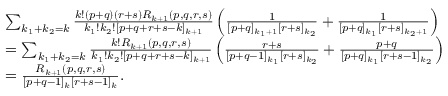Convert formula to latex. <formula><loc_0><loc_0><loc_500><loc_500>\begin{array} { r l } & { \sum _ { k _ { 1 } + k _ { 2 } = k } \frac { k ! ( p + q ) ( r + s ) R _ { k + 1 } ( p , q , r , s ) } { k _ { 1 } ! k _ { 2 } ! [ p + q + r + s - k ] _ { k + 1 } } \left ( \frac { 1 } { [ p + q ] _ { k _ { 1 } + 1 } [ r + s ] _ { k _ { 2 } } } + \frac { 1 } { [ p + q ] _ { k _ { 1 } } [ r + s ] _ { k _ { 2 } + 1 } } \right ) } \\ & { = \sum _ { k _ { 1 } + k _ { 2 } = k } \frac { k ! R _ { k + 1 } ( p , q , r , s ) } { k _ { 1 } ! k _ { 2 } ! [ p + q + r + s - k ] _ { k + 1 } } \left ( \frac { r + s } { [ p + q - 1 ] _ { k _ { 1 } } [ r + s ] _ { k _ { 2 } } } + \frac { p + q } { [ p + q ] _ { k _ { 1 } } [ r + s - 1 ] _ { k _ { 2 } } } \right ) } \\ & { = \frac { R _ { k + 1 } ( p , q , r , s ) } { [ p + q - 1 ] _ { k } [ r + s - 1 ] _ { k } } . } \end{array}</formula> 